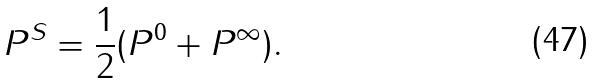Convert formula to latex. <formula><loc_0><loc_0><loc_500><loc_500>P ^ { S } = \frac { 1 } { 2 } ( P ^ { 0 } + P ^ { \infty } ) .</formula> 